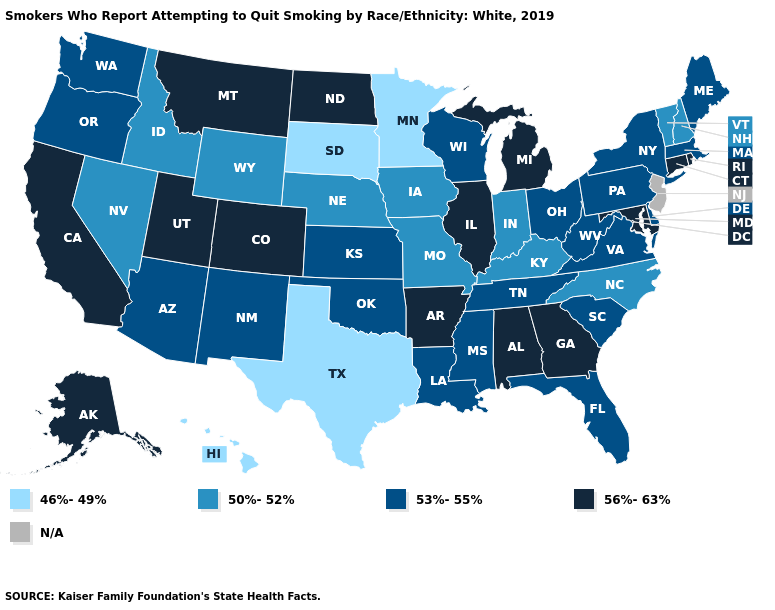What is the value of Ohio?
Concise answer only. 53%-55%. Among the states that border Arizona , which have the lowest value?
Be succinct. Nevada. What is the lowest value in the Northeast?
Give a very brief answer. 50%-52%. Among the states that border Washington , does Idaho have the lowest value?
Keep it brief. Yes. Name the states that have a value in the range 56%-63%?
Write a very short answer. Alabama, Alaska, Arkansas, California, Colorado, Connecticut, Georgia, Illinois, Maryland, Michigan, Montana, North Dakota, Rhode Island, Utah. Which states have the lowest value in the MidWest?
Write a very short answer. Minnesota, South Dakota. What is the lowest value in states that border Iowa?
Keep it brief. 46%-49%. Does Illinois have the highest value in the MidWest?
Be succinct. Yes. Name the states that have a value in the range 53%-55%?
Concise answer only. Arizona, Delaware, Florida, Kansas, Louisiana, Maine, Massachusetts, Mississippi, New Mexico, New York, Ohio, Oklahoma, Oregon, Pennsylvania, South Carolina, Tennessee, Virginia, Washington, West Virginia, Wisconsin. Does Connecticut have the highest value in the Northeast?
Answer briefly. Yes. Which states have the lowest value in the USA?
Keep it brief. Hawaii, Minnesota, South Dakota, Texas. What is the value of Idaho?
Short answer required. 50%-52%. Among the states that border New Hampshire , which have the highest value?
Give a very brief answer. Maine, Massachusetts. 